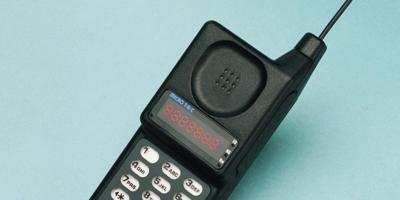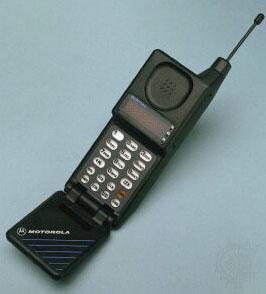The first image is the image on the left, the second image is the image on the right. For the images displayed, is the sentence "Both phones are pointing to the right." factually correct? Answer yes or no. Yes. 